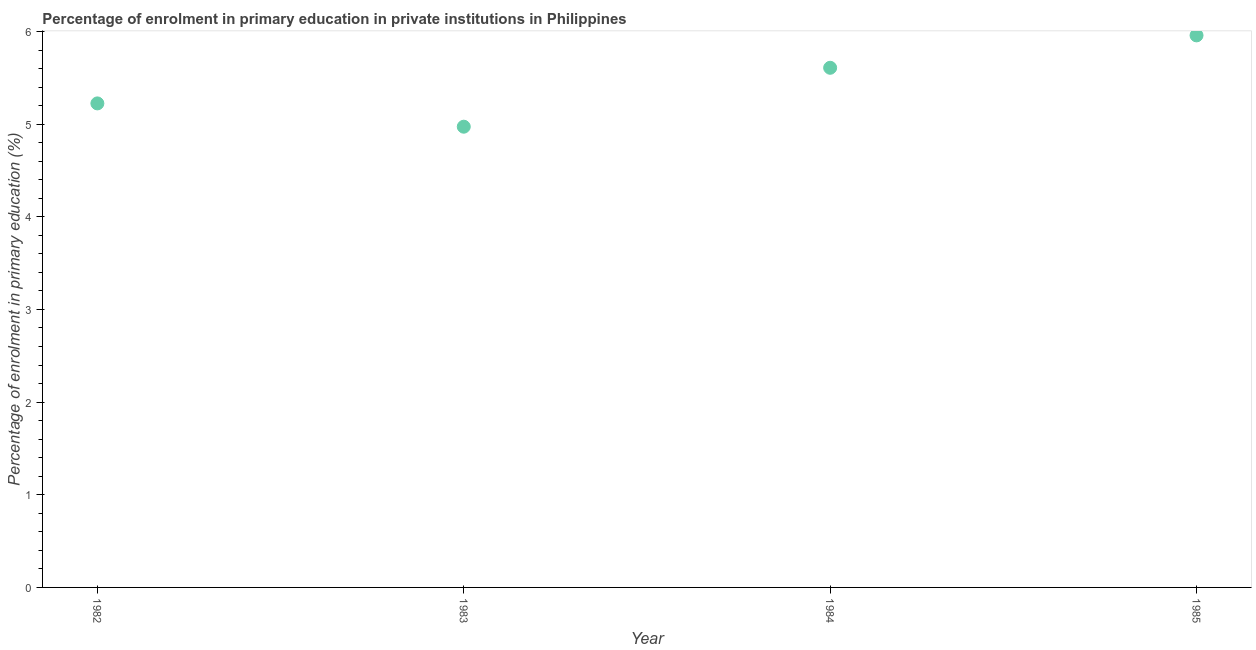What is the enrolment percentage in primary education in 1985?
Your answer should be very brief. 5.96. Across all years, what is the maximum enrolment percentage in primary education?
Your answer should be very brief. 5.96. Across all years, what is the minimum enrolment percentage in primary education?
Make the answer very short. 4.97. In which year was the enrolment percentage in primary education minimum?
Offer a very short reply. 1983. What is the sum of the enrolment percentage in primary education?
Provide a succinct answer. 21.76. What is the difference between the enrolment percentage in primary education in 1984 and 1985?
Ensure brevity in your answer.  -0.35. What is the average enrolment percentage in primary education per year?
Provide a short and direct response. 5.44. What is the median enrolment percentage in primary education?
Make the answer very short. 5.42. In how many years, is the enrolment percentage in primary education greater than 5.6 %?
Provide a short and direct response. 2. Do a majority of the years between 1983 and 1985 (inclusive) have enrolment percentage in primary education greater than 3.6 %?
Give a very brief answer. Yes. What is the ratio of the enrolment percentage in primary education in 1984 to that in 1985?
Offer a terse response. 0.94. Is the difference between the enrolment percentage in primary education in 1983 and 1984 greater than the difference between any two years?
Your answer should be compact. No. What is the difference between the highest and the second highest enrolment percentage in primary education?
Provide a short and direct response. 0.35. Is the sum of the enrolment percentage in primary education in 1983 and 1985 greater than the maximum enrolment percentage in primary education across all years?
Offer a very short reply. Yes. What is the difference between the highest and the lowest enrolment percentage in primary education?
Give a very brief answer. 0.99. In how many years, is the enrolment percentage in primary education greater than the average enrolment percentage in primary education taken over all years?
Your answer should be very brief. 2. How many dotlines are there?
Offer a very short reply. 1. How many years are there in the graph?
Keep it short and to the point. 4. What is the difference between two consecutive major ticks on the Y-axis?
Your answer should be very brief. 1. Are the values on the major ticks of Y-axis written in scientific E-notation?
Your answer should be compact. No. Does the graph contain any zero values?
Provide a succinct answer. No. Does the graph contain grids?
Give a very brief answer. No. What is the title of the graph?
Offer a terse response. Percentage of enrolment in primary education in private institutions in Philippines. What is the label or title of the Y-axis?
Offer a terse response. Percentage of enrolment in primary education (%). What is the Percentage of enrolment in primary education (%) in 1982?
Your response must be concise. 5.22. What is the Percentage of enrolment in primary education (%) in 1983?
Give a very brief answer. 4.97. What is the Percentage of enrolment in primary education (%) in 1984?
Your answer should be very brief. 5.61. What is the Percentage of enrolment in primary education (%) in 1985?
Provide a succinct answer. 5.96. What is the difference between the Percentage of enrolment in primary education (%) in 1982 and 1983?
Make the answer very short. 0.25. What is the difference between the Percentage of enrolment in primary education (%) in 1982 and 1984?
Offer a terse response. -0.38. What is the difference between the Percentage of enrolment in primary education (%) in 1982 and 1985?
Provide a short and direct response. -0.73. What is the difference between the Percentage of enrolment in primary education (%) in 1983 and 1984?
Provide a short and direct response. -0.64. What is the difference between the Percentage of enrolment in primary education (%) in 1983 and 1985?
Give a very brief answer. -0.99. What is the difference between the Percentage of enrolment in primary education (%) in 1984 and 1985?
Ensure brevity in your answer.  -0.35. What is the ratio of the Percentage of enrolment in primary education (%) in 1982 to that in 1983?
Your response must be concise. 1.05. What is the ratio of the Percentage of enrolment in primary education (%) in 1982 to that in 1985?
Provide a short and direct response. 0.88. What is the ratio of the Percentage of enrolment in primary education (%) in 1983 to that in 1984?
Keep it short and to the point. 0.89. What is the ratio of the Percentage of enrolment in primary education (%) in 1983 to that in 1985?
Your answer should be compact. 0.83. What is the ratio of the Percentage of enrolment in primary education (%) in 1984 to that in 1985?
Provide a succinct answer. 0.94. 